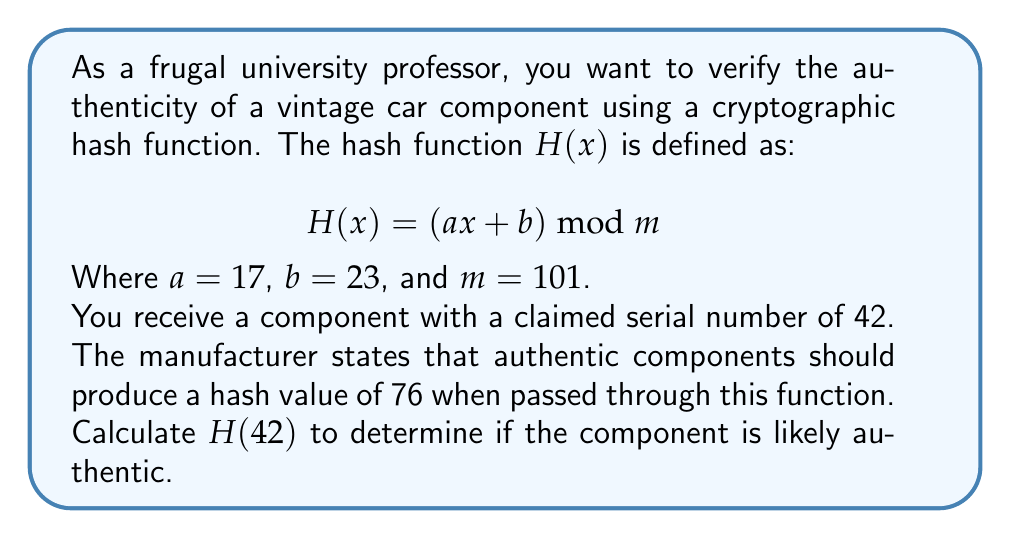Solve this math problem. To determine if the component is likely authentic, we need to calculate $H(42)$ using the given hash function and compare it to the expected value of 76.

Step 1: Substitute the values into the hash function equation:
$$H(42) = (17 \cdot 42 + 23) \bmod 101$$

Step 2: Multiply 17 and 42:
$$H(42) = (714 + 23) \bmod 101$$

Step 3: Add 23 to 714:
$$H(42) = 737 \bmod 101$$

Step 4: Perform the modulo operation:
$737 \div 101 = 7$ remainder $30$
Therefore, $737 \bmod 101 = 30$

Step 5: Compare the result to the expected value:
The calculated hash value (30) does not match the expected value (76).

Conclusion: Since the calculated hash value doesn't match the expected value, the component is likely not authentic.
Answer: 30; likely not authentic 